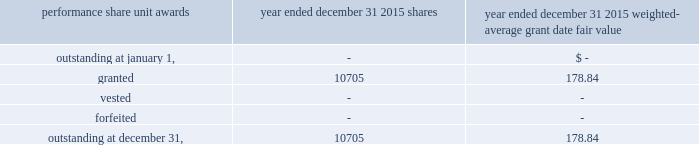The table summarized the status of the company 2019s non-vested performance share unit awards and changes for the period indicated : weighted- average grant date performance share unit awards shares fair value .
19 .
Segment reporting the u.s .
Reinsurance operation writes property and casualty reinsurance and specialty lines of business , including marine , aviation , surety and accident and health ( 201ca&h 201d ) business , on both a treaty and facultative basis , through reinsurance brokers , as well as directly with ceding companies primarily within the u.s .
The international operation writes non-u.s .
Property and casualty reinsurance through everest re 2019s branches in canada and singapore and through offices in brazil , miami and new jersey .
The bermuda operation provides reinsurance and insurance to worldwide property and casualty markets through brokers and directly with ceding companies from its bermuda office and reinsurance to the united kingdom and european markets through its uk branch and ireland re .
The insurance operation writes property and casualty insurance directly and through general agents , brokers and surplus lines brokers within the u.s .
And canada .
The mt .
Logan re segment represents business written for the segregated accounts of mt .
Logan re , which were formed on july 1 , 2013 .
The mt .
Logan re business represents a diversified set of catastrophe exposures , diversified by risk/peril and across different geographical regions globally .
These segments , with the exception of mt .
Logan re , are managed independently , but conform with corporate guidelines with respect to pricing , risk management , control of aggregate catastrophe exposures , capital , investments and support operations .
Management generally monitors and evaluates the financial performance of these operating segments based upon their underwriting results .
The mt .
Logan re segment is managed independently and seeks to write a diverse portfolio of catastrophe risks for each segregated account to achieve desired risk and return criteria .
Underwriting results include earned premium less losses and loss adjustment expenses ( 201clae 201d ) incurred , commission and brokerage expenses and other underwriting expenses .
We measure our underwriting results using ratios , in particular loss , commission and brokerage and other underwriting expense ratios , which , respectively , divide incurred losses , commissions and brokerage and other underwriting expenses by premiums earned .
Mt .
Logan re 2019s business is sourced through operating subsidiaries of the company ; however , the activity is only reflected in the mt .
Logan re segment .
For other inter-affiliate reinsurance , business is generally reported within the segment in which the business was first produced , consistent with how the business is managed .
Except for mt .
Logan re , the company does not maintain separate balance sheet data for its operating segments .
Accordingly , the company does not review and evaluate the financial results of its operating segments based upon balance sheet data. .
What is the total value of granted shares of everest re during 2015 , in millions? 
Computations: ((10705 * 178.84) / 1000000)
Answer: 1.91448. 